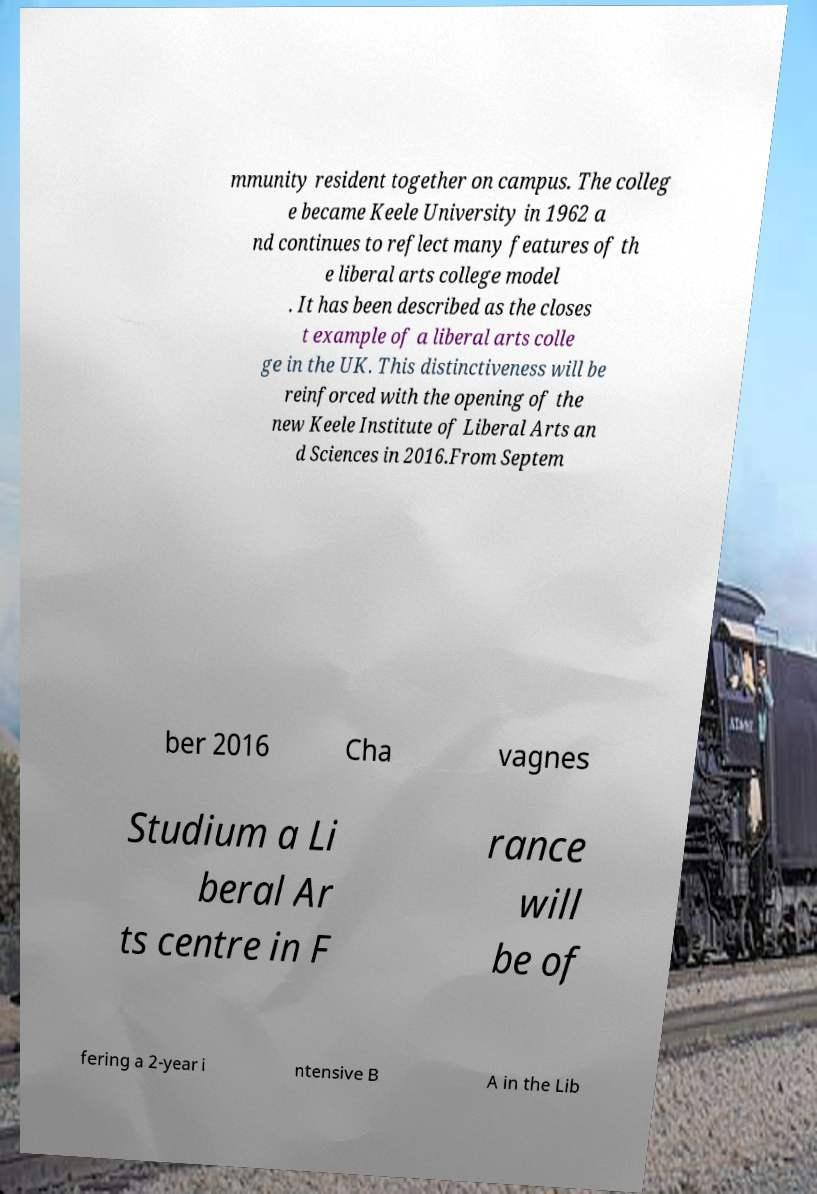Could you assist in decoding the text presented in this image and type it out clearly? mmunity resident together on campus. The colleg e became Keele University in 1962 a nd continues to reflect many features of th e liberal arts college model . It has been described as the closes t example of a liberal arts colle ge in the UK. This distinctiveness will be reinforced with the opening of the new Keele Institute of Liberal Arts an d Sciences in 2016.From Septem ber 2016 Cha vagnes Studium a Li beral Ar ts centre in F rance will be of fering a 2-year i ntensive B A in the Lib 